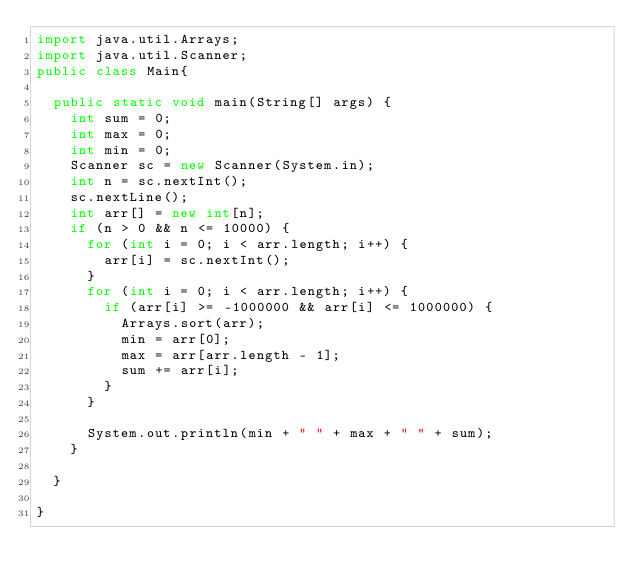Convert code to text. <code><loc_0><loc_0><loc_500><loc_500><_Java_>import java.util.Arrays;
import java.util.Scanner;
public class Main{

	public static void main(String[] args) {
		int sum = 0;
		int max = 0;
		int min = 0;
		Scanner sc = new Scanner(System.in);
		int n = sc.nextInt();
		sc.nextLine();
		int arr[] = new int[n];
		if (n > 0 && n <= 10000) {
			for (int i = 0; i < arr.length; i++) {
				arr[i] = sc.nextInt();
			}
			for (int i = 0; i < arr.length; i++) {
				if (arr[i] >= -1000000 && arr[i] <= 1000000) {
					Arrays.sort(arr);
					min = arr[0];
					max = arr[arr.length - 1];
					sum += arr[i];
				}
			}

			System.out.println(min + " " + max + " " + sum);
		}

	}

}</code> 